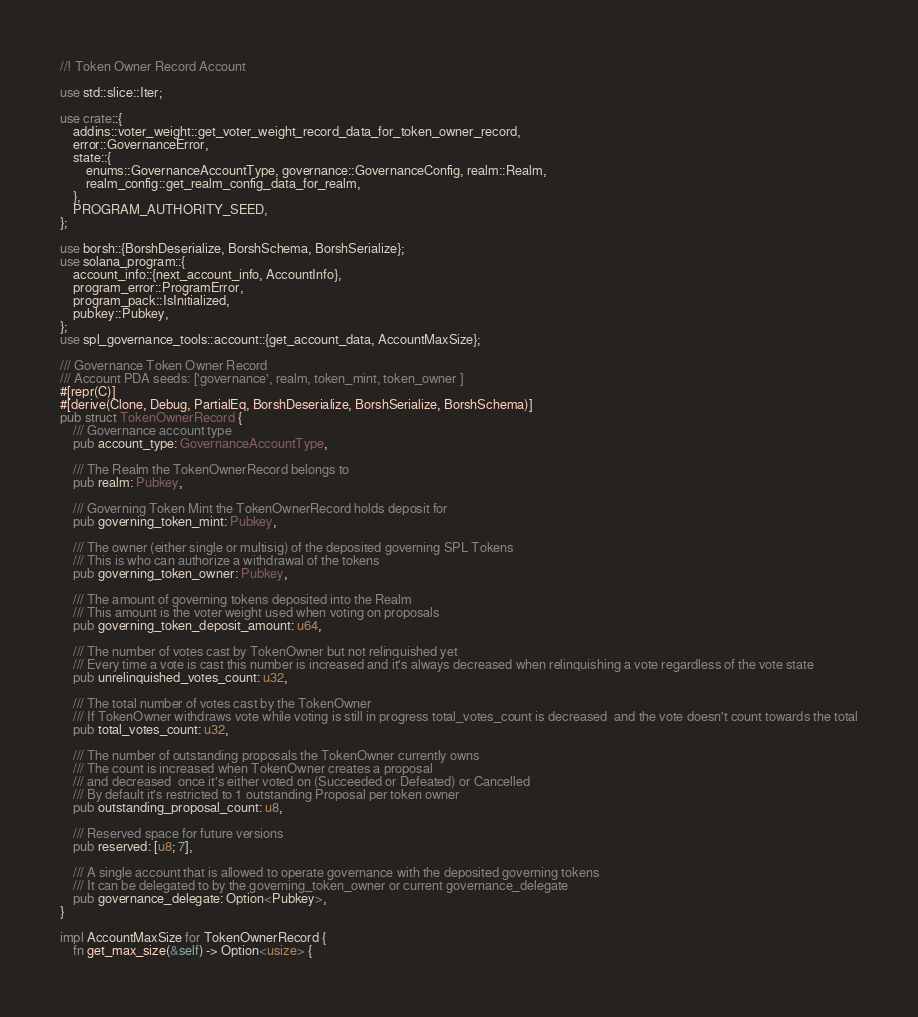<code> <loc_0><loc_0><loc_500><loc_500><_Rust_>//! Token Owner Record Account

use std::slice::Iter;

use crate::{
    addins::voter_weight::get_voter_weight_record_data_for_token_owner_record,
    error::GovernanceError,
    state::{
        enums::GovernanceAccountType, governance::GovernanceConfig, realm::Realm,
        realm_config::get_realm_config_data_for_realm,
    },
    PROGRAM_AUTHORITY_SEED,
};

use borsh::{BorshDeserialize, BorshSchema, BorshSerialize};
use solana_program::{
    account_info::{next_account_info, AccountInfo},
    program_error::ProgramError,
    program_pack::IsInitialized,
    pubkey::Pubkey,
};
use spl_governance_tools::account::{get_account_data, AccountMaxSize};

/// Governance Token Owner Record
/// Account PDA seeds: ['governance', realm, token_mint, token_owner ]
#[repr(C)]
#[derive(Clone, Debug, PartialEq, BorshDeserialize, BorshSerialize, BorshSchema)]
pub struct TokenOwnerRecord {
    /// Governance account type
    pub account_type: GovernanceAccountType,

    /// The Realm the TokenOwnerRecord belongs to
    pub realm: Pubkey,

    /// Governing Token Mint the TokenOwnerRecord holds deposit for
    pub governing_token_mint: Pubkey,

    /// The owner (either single or multisig) of the deposited governing SPL Tokens
    /// This is who can authorize a withdrawal of the tokens
    pub governing_token_owner: Pubkey,

    /// The amount of governing tokens deposited into the Realm
    /// This amount is the voter weight used when voting on proposals
    pub governing_token_deposit_amount: u64,

    /// The number of votes cast by TokenOwner but not relinquished yet
    /// Every time a vote is cast this number is increased and it's always decreased when relinquishing a vote regardless of the vote state
    pub unrelinquished_votes_count: u32,

    /// The total number of votes cast by the TokenOwner
    /// If TokenOwner withdraws vote while voting is still in progress total_votes_count is decreased  and the vote doesn't count towards the total
    pub total_votes_count: u32,

    /// The number of outstanding proposals the TokenOwner currently owns
    /// The count is increased when TokenOwner creates a proposal
    /// and decreased  once it's either voted on (Succeeded or Defeated) or Cancelled
    /// By default it's restricted to 1 outstanding Proposal per token owner
    pub outstanding_proposal_count: u8,

    /// Reserved space for future versions
    pub reserved: [u8; 7],

    /// A single account that is allowed to operate governance with the deposited governing tokens
    /// It can be delegated to by the governing_token_owner or current governance_delegate
    pub governance_delegate: Option<Pubkey>,
}

impl AccountMaxSize for TokenOwnerRecord {
    fn get_max_size(&self) -> Option<usize> {</code> 